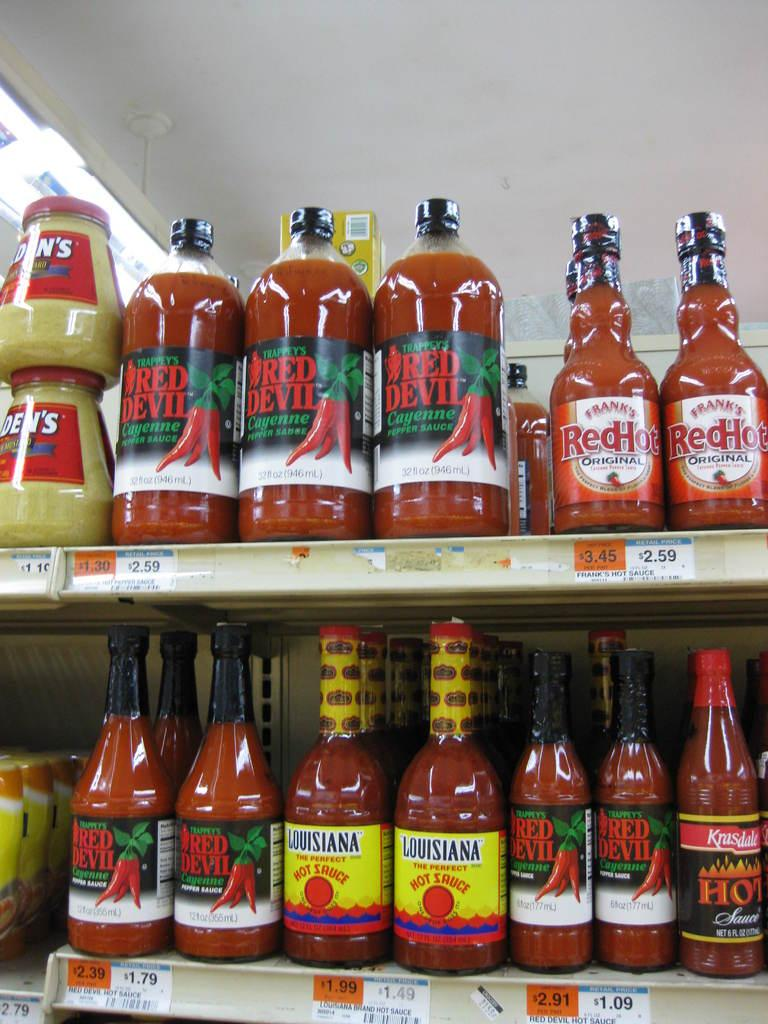<image>
Offer a succinct explanation of the picture presented. Store selling many hot sauces including Frank's Red Hot. 